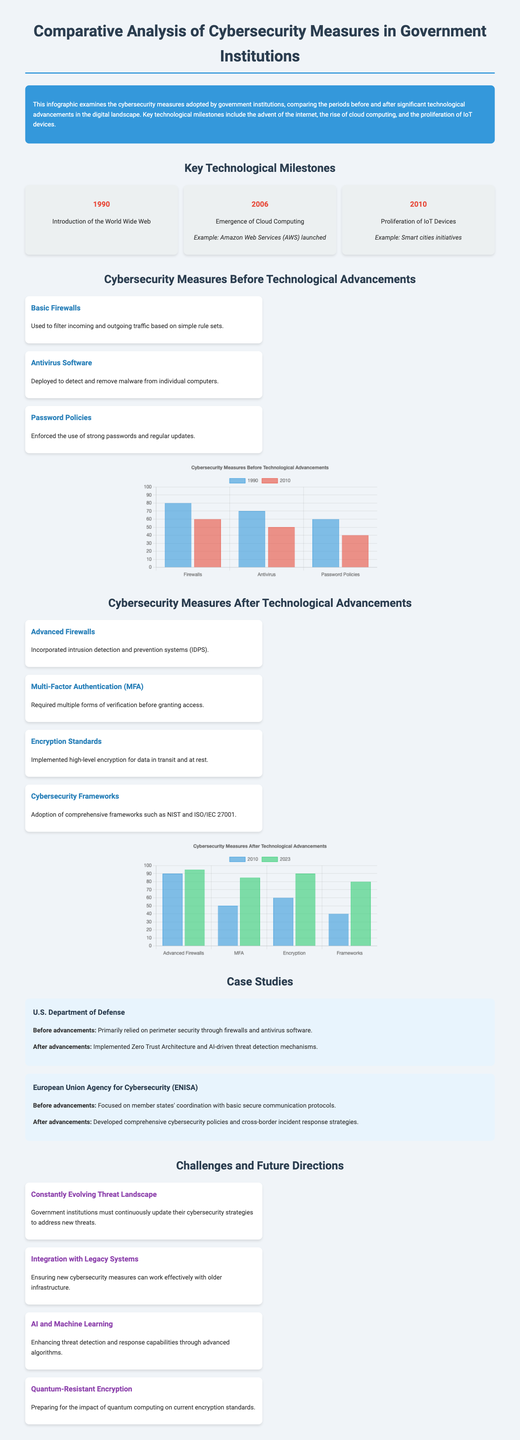What year did the World Wide Web get introduced? The document states that the World Wide Web was introduced in 1990.
Answer: 1990 What type of authentication became common after technological advancements? The document mentions Multi-Factor Authentication (MFA) as a cybersecurity measure adopted after advancements.
Answer: Multi-Factor Authentication (MFA) Which cybersecurity measure was implemented in the U.S. Department of Defense after advancements? The document indicates that the U.S. Department of Defense adopted Zero Trust Architecture following advancements.
Answer: Zero Trust Architecture What was the level of use for Advanced Firewalls in 2023? According to the chart, the use level for Advanced Firewalls in 2023 is 95.
Answer: 95 What challenge must government institutions face according to the document? The document states that the constantly evolving threat landscape is a challenge for government institutions.
Answer: Constantly Evolving Threat Landscape What is the focus of the European Union Agency for Cybersecurity (ENISA) before advancements? The document highlights that before advancements, ENISA focused on coordination with basic secure communication protocols.
Answer: Basic secure communication protocols What percentage of use was reported for Antivirus Software in 2010? The chart indicates that the percentage of use for Antivirus Software in 2010 was 50.
Answer: 50 What encryption development is mentioned as a future direction? The document states that quantum-resistant encryption is a future direction to prepare for the impact of quantum computing.
Answer: Quantum-Resistant Encryption 